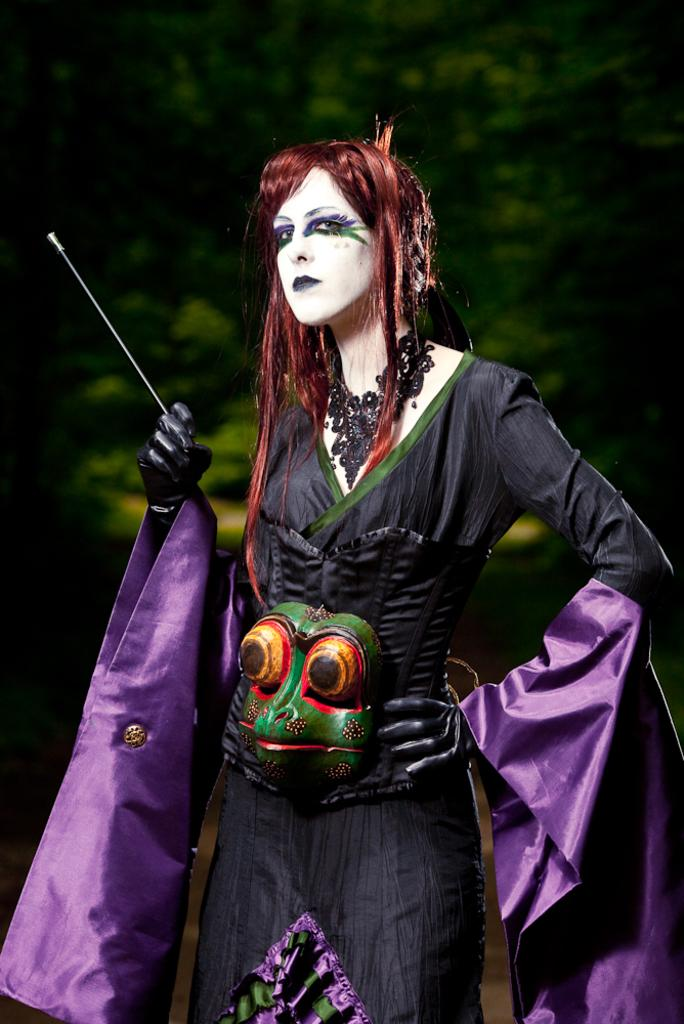What is the main subject of the image? There is a person in the image. What is the person wearing? The person is wearing a costume. What can be seen in the background of the image? There appears to be a tree in the background of the image. How would you describe the quality of the image? The image is blurry. What type of cream can be seen on the person's face in the image? There is no cream visible on the person's face in the image. What does the hen need to do in the image? There is no hen present in the image. 